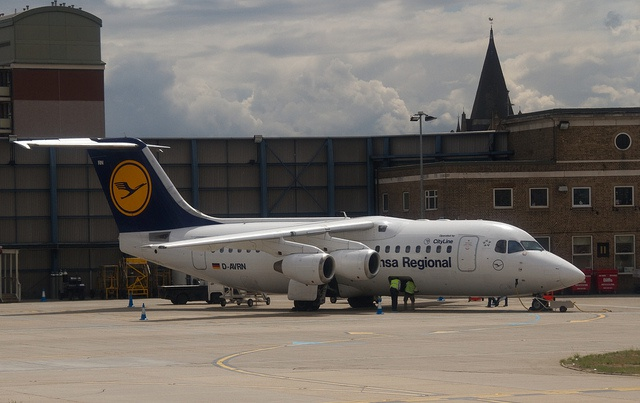Describe the objects in this image and their specific colors. I can see airplane in gray, black, darkgray, and lightgray tones, truck in gray, black, and darkgray tones, people in gray, black, and darkgreen tones, and people in gray, black, and darkgreen tones in this image. 